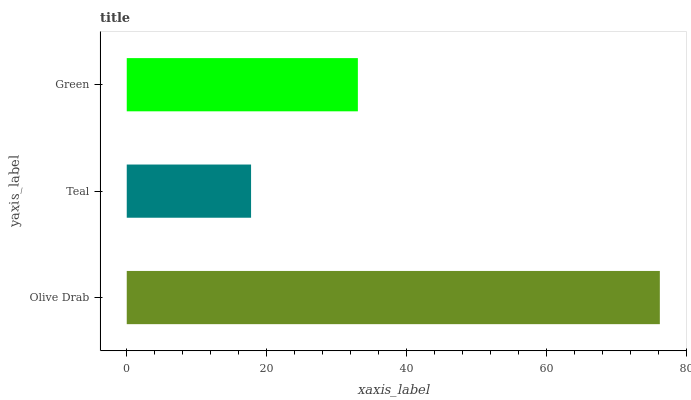Is Teal the minimum?
Answer yes or no. Yes. Is Olive Drab the maximum?
Answer yes or no. Yes. Is Green the minimum?
Answer yes or no. No. Is Green the maximum?
Answer yes or no. No. Is Green greater than Teal?
Answer yes or no. Yes. Is Teal less than Green?
Answer yes or no. Yes. Is Teal greater than Green?
Answer yes or no. No. Is Green less than Teal?
Answer yes or no. No. Is Green the high median?
Answer yes or no. Yes. Is Green the low median?
Answer yes or no. Yes. Is Olive Drab the high median?
Answer yes or no. No. Is Olive Drab the low median?
Answer yes or no. No. 